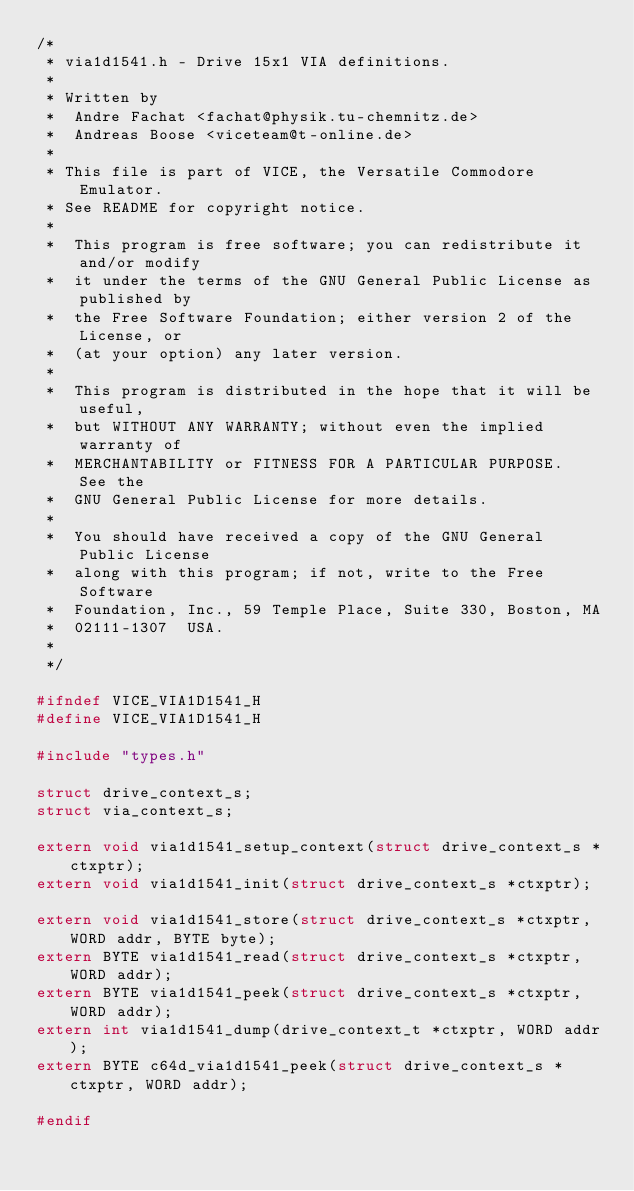Convert code to text. <code><loc_0><loc_0><loc_500><loc_500><_C_>/*
 * via1d1541.h - Drive 15x1 VIA definitions.
 *
 * Written by
 *  Andre Fachat <fachat@physik.tu-chemnitz.de>
 *  Andreas Boose <viceteam@t-online.de>
 *
 * This file is part of VICE, the Versatile Commodore Emulator.
 * See README for copyright notice.
 *
 *  This program is free software; you can redistribute it and/or modify
 *  it under the terms of the GNU General Public License as published by
 *  the Free Software Foundation; either version 2 of the License, or
 *  (at your option) any later version.
 *
 *  This program is distributed in the hope that it will be useful,
 *  but WITHOUT ANY WARRANTY; without even the implied warranty of
 *  MERCHANTABILITY or FITNESS FOR A PARTICULAR PURPOSE.  See the
 *  GNU General Public License for more details.
 *
 *  You should have received a copy of the GNU General Public License
 *  along with this program; if not, write to the Free Software
 *  Foundation, Inc., 59 Temple Place, Suite 330, Boston, MA
 *  02111-1307  USA.
 *
 */

#ifndef VICE_VIA1D1541_H
#define VICE_VIA1D1541_H

#include "types.h"

struct drive_context_s;
struct via_context_s;

extern void via1d1541_setup_context(struct drive_context_s *ctxptr);
extern void via1d1541_init(struct drive_context_s *ctxptr);

extern void via1d1541_store(struct drive_context_s *ctxptr, WORD addr, BYTE byte);
extern BYTE via1d1541_read(struct drive_context_s *ctxptr, WORD addr);
extern BYTE via1d1541_peek(struct drive_context_s *ctxptr, WORD addr);
extern int via1d1541_dump(drive_context_t *ctxptr, WORD addr);
extern BYTE c64d_via1d1541_peek(struct drive_context_s *ctxptr, WORD addr);

#endif
</code> 